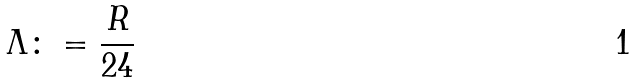Convert formula to latex. <formula><loc_0><loc_0><loc_500><loc_500>\Lambda \colon = \frac { R } { 2 4 }</formula> 